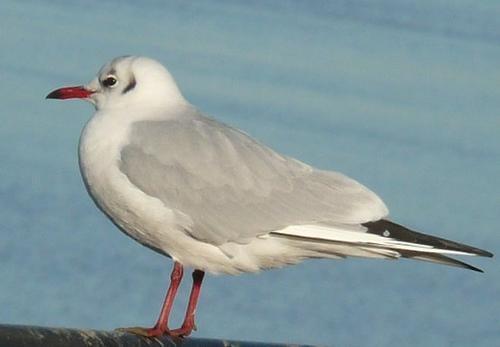How many birds are in the photo?
Give a very brief answer. 1. How many of the birds eyes are visible?
Give a very brief answer. 1. How many breaks are there?
Give a very brief answer. 1. How many birds are in the picture?
Give a very brief answer. 1. How many birds are there?
Give a very brief answer. 1. 